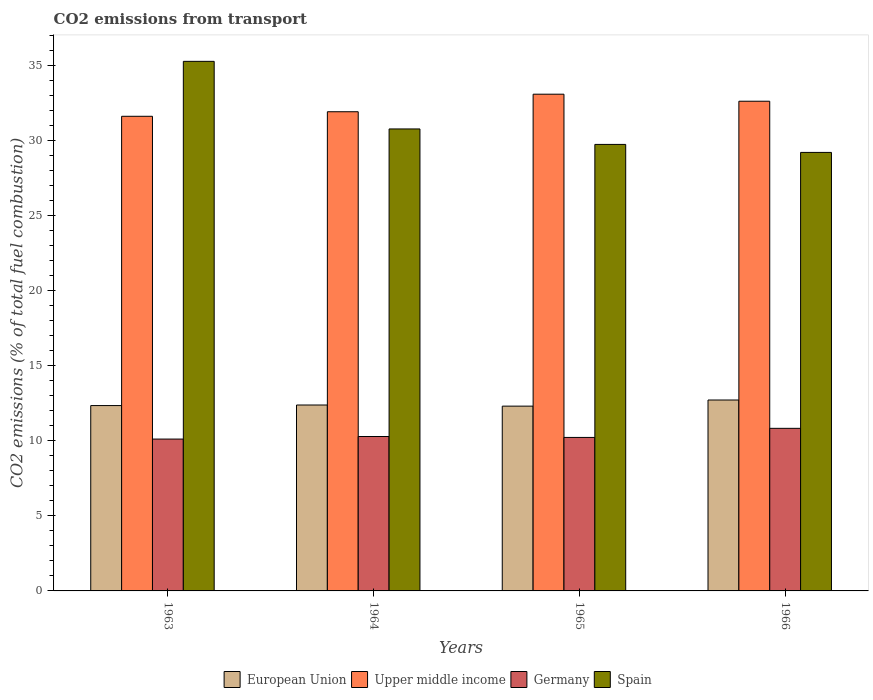How many different coloured bars are there?
Make the answer very short. 4. Are the number of bars per tick equal to the number of legend labels?
Offer a very short reply. Yes. How many bars are there on the 3rd tick from the right?
Your answer should be compact. 4. What is the label of the 2nd group of bars from the left?
Your answer should be very brief. 1964. In how many cases, is the number of bars for a given year not equal to the number of legend labels?
Your response must be concise. 0. What is the total CO2 emitted in Upper middle income in 1965?
Offer a terse response. 33.06. Across all years, what is the maximum total CO2 emitted in Germany?
Ensure brevity in your answer.  10.82. Across all years, what is the minimum total CO2 emitted in Upper middle income?
Give a very brief answer. 31.59. In which year was the total CO2 emitted in Upper middle income maximum?
Provide a short and direct response. 1965. In which year was the total CO2 emitted in Germany minimum?
Provide a short and direct response. 1963. What is the total total CO2 emitted in Spain in the graph?
Your response must be concise. 124.9. What is the difference between the total CO2 emitted in Upper middle income in 1963 and that in 1965?
Your answer should be compact. -1.47. What is the difference between the total CO2 emitted in Upper middle income in 1966 and the total CO2 emitted in European Union in 1964?
Your answer should be very brief. 20.22. What is the average total CO2 emitted in European Union per year?
Offer a terse response. 12.43. In the year 1963, what is the difference between the total CO2 emitted in European Union and total CO2 emitted in Spain?
Provide a short and direct response. -22.91. In how many years, is the total CO2 emitted in Spain greater than 18?
Give a very brief answer. 4. What is the ratio of the total CO2 emitted in Upper middle income in 1963 to that in 1965?
Your response must be concise. 0.96. Is the difference between the total CO2 emitted in European Union in 1965 and 1966 greater than the difference between the total CO2 emitted in Spain in 1965 and 1966?
Offer a very short reply. No. What is the difference between the highest and the second highest total CO2 emitted in Spain?
Offer a terse response. 4.5. What is the difference between the highest and the lowest total CO2 emitted in European Union?
Provide a short and direct response. 0.41. In how many years, is the total CO2 emitted in Upper middle income greater than the average total CO2 emitted in Upper middle income taken over all years?
Give a very brief answer. 2. What does the 2nd bar from the left in 1964 represents?
Keep it short and to the point. Upper middle income. How many bars are there?
Your answer should be very brief. 16. How many years are there in the graph?
Make the answer very short. 4. Are the values on the major ticks of Y-axis written in scientific E-notation?
Your answer should be very brief. No. Does the graph contain any zero values?
Keep it short and to the point. No. Does the graph contain grids?
Your response must be concise. No. Where does the legend appear in the graph?
Your response must be concise. Bottom center. How many legend labels are there?
Offer a terse response. 4. What is the title of the graph?
Your answer should be very brief. CO2 emissions from transport. What is the label or title of the Y-axis?
Your response must be concise. CO2 emissions (% of total fuel combustion). What is the CO2 emissions (% of total fuel combustion) in European Union in 1963?
Offer a very short reply. 12.34. What is the CO2 emissions (% of total fuel combustion) in Upper middle income in 1963?
Keep it short and to the point. 31.59. What is the CO2 emissions (% of total fuel combustion) of Germany in 1963?
Your answer should be compact. 10.11. What is the CO2 emissions (% of total fuel combustion) of Spain in 1963?
Give a very brief answer. 35.25. What is the CO2 emissions (% of total fuel combustion) in European Union in 1964?
Provide a short and direct response. 12.37. What is the CO2 emissions (% of total fuel combustion) of Upper middle income in 1964?
Your answer should be very brief. 31.89. What is the CO2 emissions (% of total fuel combustion) of Germany in 1964?
Make the answer very short. 10.28. What is the CO2 emissions (% of total fuel combustion) in Spain in 1964?
Make the answer very short. 30.75. What is the CO2 emissions (% of total fuel combustion) in European Union in 1965?
Give a very brief answer. 12.3. What is the CO2 emissions (% of total fuel combustion) of Upper middle income in 1965?
Keep it short and to the point. 33.06. What is the CO2 emissions (% of total fuel combustion) in Germany in 1965?
Keep it short and to the point. 10.22. What is the CO2 emissions (% of total fuel combustion) in Spain in 1965?
Provide a succinct answer. 29.72. What is the CO2 emissions (% of total fuel combustion) in European Union in 1966?
Your response must be concise. 12.71. What is the CO2 emissions (% of total fuel combustion) in Upper middle income in 1966?
Offer a terse response. 32.59. What is the CO2 emissions (% of total fuel combustion) of Germany in 1966?
Offer a terse response. 10.82. What is the CO2 emissions (% of total fuel combustion) of Spain in 1966?
Offer a very short reply. 29.19. Across all years, what is the maximum CO2 emissions (% of total fuel combustion) of European Union?
Give a very brief answer. 12.71. Across all years, what is the maximum CO2 emissions (% of total fuel combustion) in Upper middle income?
Your answer should be compact. 33.06. Across all years, what is the maximum CO2 emissions (% of total fuel combustion) of Germany?
Offer a terse response. 10.82. Across all years, what is the maximum CO2 emissions (% of total fuel combustion) in Spain?
Offer a terse response. 35.25. Across all years, what is the minimum CO2 emissions (% of total fuel combustion) of European Union?
Your response must be concise. 12.3. Across all years, what is the minimum CO2 emissions (% of total fuel combustion) in Upper middle income?
Your answer should be compact. 31.59. Across all years, what is the minimum CO2 emissions (% of total fuel combustion) of Germany?
Offer a very short reply. 10.11. Across all years, what is the minimum CO2 emissions (% of total fuel combustion) of Spain?
Provide a short and direct response. 29.19. What is the total CO2 emissions (% of total fuel combustion) of European Union in the graph?
Your response must be concise. 49.72. What is the total CO2 emissions (% of total fuel combustion) of Upper middle income in the graph?
Offer a very short reply. 129.14. What is the total CO2 emissions (% of total fuel combustion) of Germany in the graph?
Keep it short and to the point. 41.42. What is the total CO2 emissions (% of total fuel combustion) of Spain in the graph?
Provide a succinct answer. 124.9. What is the difference between the CO2 emissions (% of total fuel combustion) in European Union in 1963 and that in 1964?
Keep it short and to the point. -0.04. What is the difference between the CO2 emissions (% of total fuel combustion) of Upper middle income in 1963 and that in 1964?
Provide a short and direct response. -0.3. What is the difference between the CO2 emissions (% of total fuel combustion) in Germany in 1963 and that in 1964?
Provide a succinct answer. -0.17. What is the difference between the CO2 emissions (% of total fuel combustion) of Spain in 1963 and that in 1964?
Ensure brevity in your answer.  4.5. What is the difference between the CO2 emissions (% of total fuel combustion) in European Union in 1963 and that in 1965?
Your response must be concise. 0.04. What is the difference between the CO2 emissions (% of total fuel combustion) in Upper middle income in 1963 and that in 1965?
Your response must be concise. -1.47. What is the difference between the CO2 emissions (% of total fuel combustion) of Germany in 1963 and that in 1965?
Your answer should be very brief. -0.11. What is the difference between the CO2 emissions (% of total fuel combustion) in Spain in 1963 and that in 1965?
Your answer should be very brief. 5.53. What is the difference between the CO2 emissions (% of total fuel combustion) of European Union in 1963 and that in 1966?
Your response must be concise. -0.37. What is the difference between the CO2 emissions (% of total fuel combustion) of Upper middle income in 1963 and that in 1966?
Provide a succinct answer. -1. What is the difference between the CO2 emissions (% of total fuel combustion) in Germany in 1963 and that in 1966?
Offer a very short reply. -0.71. What is the difference between the CO2 emissions (% of total fuel combustion) of Spain in 1963 and that in 1966?
Keep it short and to the point. 6.06. What is the difference between the CO2 emissions (% of total fuel combustion) of European Union in 1964 and that in 1965?
Your answer should be compact. 0.07. What is the difference between the CO2 emissions (% of total fuel combustion) of Upper middle income in 1964 and that in 1965?
Provide a succinct answer. -1.17. What is the difference between the CO2 emissions (% of total fuel combustion) of Germany in 1964 and that in 1965?
Your answer should be compact. 0.06. What is the difference between the CO2 emissions (% of total fuel combustion) of Spain in 1964 and that in 1965?
Your answer should be compact. 1.03. What is the difference between the CO2 emissions (% of total fuel combustion) of European Union in 1964 and that in 1966?
Your answer should be very brief. -0.33. What is the difference between the CO2 emissions (% of total fuel combustion) in Upper middle income in 1964 and that in 1966?
Keep it short and to the point. -0.7. What is the difference between the CO2 emissions (% of total fuel combustion) in Germany in 1964 and that in 1966?
Offer a very short reply. -0.54. What is the difference between the CO2 emissions (% of total fuel combustion) of Spain in 1964 and that in 1966?
Make the answer very short. 1.56. What is the difference between the CO2 emissions (% of total fuel combustion) of European Union in 1965 and that in 1966?
Your response must be concise. -0.41. What is the difference between the CO2 emissions (% of total fuel combustion) of Upper middle income in 1965 and that in 1966?
Offer a very short reply. 0.47. What is the difference between the CO2 emissions (% of total fuel combustion) in Germany in 1965 and that in 1966?
Make the answer very short. -0.61. What is the difference between the CO2 emissions (% of total fuel combustion) of Spain in 1965 and that in 1966?
Offer a terse response. 0.53. What is the difference between the CO2 emissions (% of total fuel combustion) in European Union in 1963 and the CO2 emissions (% of total fuel combustion) in Upper middle income in 1964?
Offer a terse response. -19.56. What is the difference between the CO2 emissions (% of total fuel combustion) of European Union in 1963 and the CO2 emissions (% of total fuel combustion) of Germany in 1964?
Offer a terse response. 2.06. What is the difference between the CO2 emissions (% of total fuel combustion) in European Union in 1963 and the CO2 emissions (% of total fuel combustion) in Spain in 1964?
Keep it short and to the point. -18.41. What is the difference between the CO2 emissions (% of total fuel combustion) in Upper middle income in 1963 and the CO2 emissions (% of total fuel combustion) in Germany in 1964?
Offer a terse response. 21.31. What is the difference between the CO2 emissions (% of total fuel combustion) of Upper middle income in 1963 and the CO2 emissions (% of total fuel combustion) of Spain in 1964?
Offer a terse response. 0.84. What is the difference between the CO2 emissions (% of total fuel combustion) in Germany in 1963 and the CO2 emissions (% of total fuel combustion) in Spain in 1964?
Ensure brevity in your answer.  -20.64. What is the difference between the CO2 emissions (% of total fuel combustion) of European Union in 1963 and the CO2 emissions (% of total fuel combustion) of Upper middle income in 1965?
Offer a very short reply. -20.73. What is the difference between the CO2 emissions (% of total fuel combustion) of European Union in 1963 and the CO2 emissions (% of total fuel combustion) of Germany in 1965?
Ensure brevity in your answer.  2.12. What is the difference between the CO2 emissions (% of total fuel combustion) of European Union in 1963 and the CO2 emissions (% of total fuel combustion) of Spain in 1965?
Your response must be concise. -17.38. What is the difference between the CO2 emissions (% of total fuel combustion) of Upper middle income in 1963 and the CO2 emissions (% of total fuel combustion) of Germany in 1965?
Provide a succinct answer. 21.38. What is the difference between the CO2 emissions (% of total fuel combustion) of Upper middle income in 1963 and the CO2 emissions (% of total fuel combustion) of Spain in 1965?
Your answer should be very brief. 1.87. What is the difference between the CO2 emissions (% of total fuel combustion) of Germany in 1963 and the CO2 emissions (% of total fuel combustion) of Spain in 1965?
Give a very brief answer. -19.61. What is the difference between the CO2 emissions (% of total fuel combustion) in European Union in 1963 and the CO2 emissions (% of total fuel combustion) in Upper middle income in 1966?
Make the answer very short. -20.26. What is the difference between the CO2 emissions (% of total fuel combustion) in European Union in 1963 and the CO2 emissions (% of total fuel combustion) in Germany in 1966?
Provide a succinct answer. 1.52. What is the difference between the CO2 emissions (% of total fuel combustion) in European Union in 1963 and the CO2 emissions (% of total fuel combustion) in Spain in 1966?
Offer a terse response. -16.85. What is the difference between the CO2 emissions (% of total fuel combustion) of Upper middle income in 1963 and the CO2 emissions (% of total fuel combustion) of Germany in 1966?
Provide a succinct answer. 20.77. What is the difference between the CO2 emissions (% of total fuel combustion) of Upper middle income in 1963 and the CO2 emissions (% of total fuel combustion) of Spain in 1966?
Provide a succinct answer. 2.4. What is the difference between the CO2 emissions (% of total fuel combustion) of Germany in 1963 and the CO2 emissions (% of total fuel combustion) of Spain in 1966?
Offer a very short reply. -19.08. What is the difference between the CO2 emissions (% of total fuel combustion) of European Union in 1964 and the CO2 emissions (% of total fuel combustion) of Upper middle income in 1965?
Offer a terse response. -20.69. What is the difference between the CO2 emissions (% of total fuel combustion) of European Union in 1964 and the CO2 emissions (% of total fuel combustion) of Germany in 1965?
Give a very brief answer. 2.16. What is the difference between the CO2 emissions (% of total fuel combustion) in European Union in 1964 and the CO2 emissions (% of total fuel combustion) in Spain in 1965?
Provide a succinct answer. -17.35. What is the difference between the CO2 emissions (% of total fuel combustion) in Upper middle income in 1964 and the CO2 emissions (% of total fuel combustion) in Germany in 1965?
Keep it short and to the point. 21.68. What is the difference between the CO2 emissions (% of total fuel combustion) in Upper middle income in 1964 and the CO2 emissions (% of total fuel combustion) in Spain in 1965?
Keep it short and to the point. 2.17. What is the difference between the CO2 emissions (% of total fuel combustion) in Germany in 1964 and the CO2 emissions (% of total fuel combustion) in Spain in 1965?
Offer a very short reply. -19.44. What is the difference between the CO2 emissions (% of total fuel combustion) of European Union in 1964 and the CO2 emissions (% of total fuel combustion) of Upper middle income in 1966?
Provide a short and direct response. -20.22. What is the difference between the CO2 emissions (% of total fuel combustion) in European Union in 1964 and the CO2 emissions (% of total fuel combustion) in Germany in 1966?
Keep it short and to the point. 1.55. What is the difference between the CO2 emissions (% of total fuel combustion) in European Union in 1964 and the CO2 emissions (% of total fuel combustion) in Spain in 1966?
Your answer should be very brief. -16.81. What is the difference between the CO2 emissions (% of total fuel combustion) of Upper middle income in 1964 and the CO2 emissions (% of total fuel combustion) of Germany in 1966?
Provide a succinct answer. 21.07. What is the difference between the CO2 emissions (% of total fuel combustion) of Upper middle income in 1964 and the CO2 emissions (% of total fuel combustion) of Spain in 1966?
Give a very brief answer. 2.71. What is the difference between the CO2 emissions (% of total fuel combustion) of Germany in 1964 and the CO2 emissions (% of total fuel combustion) of Spain in 1966?
Keep it short and to the point. -18.91. What is the difference between the CO2 emissions (% of total fuel combustion) in European Union in 1965 and the CO2 emissions (% of total fuel combustion) in Upper middle income in 1966?
Your answer should be compact. -20.29. What is the difference between the CO2 emissions (% of total fuel combustion) of European Union in 1965 and the CO2 emissions (% of total fuel combustion) of Germany in 1966?
Offer a very short reply. 1.48. What is the difference between the CO2 emissions (% of total fuel combustion) of European Union in 1965 and the CO2 emissions (% of total fuel combustion) of Spain in 1966?
Keep it short and to the point. -16.89. What is the difference between the CO2 emissions (% of total fuel combustion) in Upper middle income in 1965 and the CO2 emissions (% of total fuel combustion) in Germany in 1966?
Provide a short and direct response. 22.24. What is the difference between the CO2 emissions (% of total fuel combustion) of Upper middle income in 1965 and the CO2 emissions (% of total fuel combustion) of Spain in 1966?
Make the answer very short. 3.88. What is the difference between the CO2 emissions (% of total fuel combustion) in Germany in 1965 and the CO2 emissions (% of total fuel combustion) in Spain in 1966?
Offer a terse response. -18.97. What is the average CO2 emissions (% of total fuel combustion) in European Union per year?
Offer a very short reply. 12.43. What is the average CO2 emissions (% of total fuel combustion) in Upper middle income per year?
Offer a very short reply. 32.29. What is the average CO2 emissions (% of total fuel combustion) in Germany per year?
Your answer should be compact. 10.36. What is the average CO2 emissions (% of total fuel combustion) of Spain per year?
Your response must be concise. 31.23. In the year 1963, what is the difference between the CO2 emissions (% of total fuel combustion) of European Union and CO2 emissions (% of total fuel combustion) of Upper middle income?
Keep it short and to the point. -19.25. In the year 1963, what is the difference between the CO2 emissions (% of total fuel combustion) in European Union and CO2 emissions (% of total fuel combustion) in Germany?
Your response must be concise. 2.23. In the year 1963, what is the difference between the CO2 emissions (% of total fuel combustion) in European Union and CO2 emissions (% of total fuel combustion) in Spain?
Your answer should be compact. -22.91. In the year 1963, what is the difference between the CO2 emissions (% of total fuel combustion) in Upper middle income and CO2 emissions (% of total fuel combustion) in Germany?
Ensure brevity in your answer.  21.48. In the year 1963, what is the difference between the CO2 emissions (% of total fuel combustion) in Upper middle income and CO2 emissions (% of total fuel combustion) in Spain?
Keep it short and to the point. -3.66. In the year 1963, what is the difference between the CO2 emissions (% of total fuel combustion) of Germany and CO2 emissions (% of total fuel combustion) of Spain?
Offer a very short reply. -25.14. In the year 1964, what is the difference between the CO2 emissions (% of total fuel combustion) in European Union and CO2 emissions (% of total fuel combustion) in Upper middle income?
Provide a succinct answer. -19.52. In the year 1964, what is the difference between the CO2 emissions (% of total fuel combustion) in European Union and CO2 emissions (% of total fuel combustion) in Germany?
Your answer should be very brief. 2.1. In the year 1964, what is the difference between the CO2 emissions (% of total fuel combustion) in European Union and CO2 emissions (% of total fuel combustion) in Spain?
Provide a short and direct response. -18.37. In the year 1964, what is the difference between the CO2 emissions (% of total fuel combustion) of Upper middle income and CO2 emissions (% of total fuel combustion) of Germany?
Give a very brief answer. 21.62. In the year 1964, what is the difference between the CO2 emissions (% of total fuel combustion) of Upper middle income and CO2 emissions (% of total fuel combustion) of Spain?
Your answer should be very brief. 1.15. In the year 1964, what is the difference between the CO2 emissions (% of total fuel combustion) of Germany and CO2 emissions (% of total fuel combustion) of Spain?
Your response must be concise. -20.47. In the year 1965, what is the difference between the CO2 emissions (% of total fuel combustion) of European Union and CO2 emissions (% of total fuel combustion) of Upper middle income?
Keep it short and to the point. -20.76. In the year 1965, what is the difference between the CO2 emissions (% of total fuel combustion) of European Union and CO2 emissions (% of total fuel combustion) of Germany?
Give a very brief answer. 2.08. In the year 1965, what is the difference between the CO2 emissions (% of total fuel combustion) of European Union and CO2 emissions (% of total fuel combustion) of Spain?
Provide a succinct answer. -17.42. In the year 1965, what is the difference between the CO2 emissions (% of total fuel combustion) of Upper middle income and CO2 emissions (% of total fuel combustion) of Germany?
Provide a succinct answer. 22.85. In the year 1965, what is the difference between the CO2 emissions (% of total fuel combustion) of Upper middle income and CO2 emissions (% of total fuel combustion) of Spain?
Your response must be concise. 3.34. In the year 1965, what is the difference between the CO2 emissions (% of total fuel combustion) of Germany and CO2 emissions (% of total fuel combustion) of Spain?
Provide a succinct answer. -19.5. In the year 1966, what is the difference between the CO2 emissions (% of total fuel combustion) in European Union and CO2 emissions (% of total fuel combustion) in Upper middle income?
Keep it short and to the point. -19.89. In the year 1966, what is the difference between the CO2 emissions (% of total fuel combustion) of European Union and CO2 emissions (% of total fuel combustion) of Germany?
Offer a very short reply. 1.89. In the year 1966, what is the difference between the CO2 emissions (% of total fuel combustion) of European Union and CO2 emissions (% of total fuel combustion) of Spain?
Offer a very short reply. -16.48. In the year 1966, what is the difference between the CO2 emissions (% of total fuel combustion) of Upper middle income and CO2 emissions (% of total fuel combustion) of Germany?
Your answer should be very brief. 21.77. In the year 1966, what is the difference between the CO2 emissions (% of total fuel combustion) in Upper middle income and CO2 emissions (% of total fuel combustion) in Spain?
Offer a very short reply. 3.41. In the year 1966, what is the difference between the CO2 emissions (% of total fuel combustion) of Germany and CO2 emissions (% of total fuel combustion) of Spain?
Ensure brevity in your answer.  -18.37. What is the ratio of the CO2 emissions (% of total fuel combustion) of Upper middle income in 1963 to that in 1964?
Provide a succinct answer. 0.99. What is the ratio of the CO2 emissions (% of total fuel combustion) of Germany in 1963 to that in 1964?
Give a very brief answer. 0.98. What is the ratio of the CO2 emissions (% of total fuel combustion) in Spain in 1963 to that in 1964?
Offer a terse response. 1.15. What is the ratio of the CO2 emissions (% of total fuel combustion) in Upper middle income in 1963 to that in 1965?
Provide a short and direct response. 0.96. What is the ratio of the CO2 emissions (% of total fuel combustion) in Germany in 1963 to that in 1965?
Keep it short and to the point. 0.99. What is the ratio of the CO2 emissions (% of total fuel combustion) of Spain in 1963 to that in 1965?
Ensure brevity in your answer.  1.19. What is the ratio of the CO2 emissions (% of total fuel combustion) in European Union in 1963 to that in 1966?
Offer a terse response. 0.97. What is the ratio of the CO2 emissions (% of total fuel combustion) of Upper middle income in 1963 to that in 1966?
Give a very brief answer. 0.97. What is the ratio of the CO2 emissions (% of total fuel combustion) of Germany in 1963 to that in 1966?
Your response must be concise. 0.93. What is the ratio of the CO2 emissions (% of total fuel combustion) in Spain in 1963 to that in 1966?
Make the answer very short. 1.21. What is the ratio of the CO2 emissions (% of total fuel combustion) in European Union in 1964 to that in 1965?
Keep it short and to the point. 1.01. What is the ratio of the CO2 emissions (% of total fuel combustion) of Upper middle income in 1964 to that in 1965?
Your answer should be very brief. 0.96. What is the ratio of the CO2 emissions (% of total fuel combustion) in Spain in 1964 to that in 1965?
Keep it short and to the point. 1.03. What is the ratio of the CO2 emissions (% of total fuel combustion) in European Union in 1964 to that in 1966?
Your answer should be compact. 0.97. What is the ratio of the CO2 emissions (% of total fuel combustion) in Upper middle income in 1964 to that in 1966?
Provide a short and direct response. 0.98. What is the ratio of the CO2 emissions (% of total fuel combustion) in Germany in 1964 to that in 1966?
Offer a very short reply. 0.95. What is the ratio of the CO2 emissions (% of total fuel combustion) of Spain in 1964 to that in 1966?
Provide a succinct answer. 1.05. What is the ratio of the CO2 emissions (% of total fuel combustion) in European Union in 1965 to that in 1966?
Make the answer very short. 0.97. What is the ratio of the CO2 emissions (% of total fuel combustion) in Upper middle income in 1965 to that in 1966?
Ensure brevity in your answer.  1.01. What is the ratio of the CO2 emissions (% of total fuel combustion) of Germany in 1965 to that in 1966?
Give a very brief answer. 0.94. What is the ratio of the CO2 emissions (% of total fuel combustion) of Spain in 1965 to that in 1966?
Make the answer very short. 1.02. What is the difference between the highest and the second highest CO2 emissions (% of total fuel combustion) in European Union?
Your answer should be very brief. 0.33. What is the difference between the highest and the second highest CO2 emissions (% of total fuel combustion) of Upper middle income?
Offer a terse response. 0.47. What is the difference between the highest and the second highest CO2 emissions (% of total fuel combustion) in Germany?
Provide a short and direct response. 0.54. What is the difference between the highest and the second highest CO2 emissions (% of total fuel combustion) in Spain?
Offer a very short reply. 4.5. What is the difference between the highest and the lowest CO2 emissions (% of total fuel combustion) of European Union?
Ensure brevity in your answer.  0.41. What is the difference between the highest and the lowest CO2 emissions (% of total fuel combustion) in Upper middle income?
Provide a short and direct response. 1.47. What is the difference between the highest and the lowest CO2 emissions (% of total fuel combustion) of Germany?
Provide a succinct answer. 0.71. What is the difference between the highest and the lowest CO2 emissions (% of total fuel combustion) in Spain?
Give a very brief answer. 6.06. 